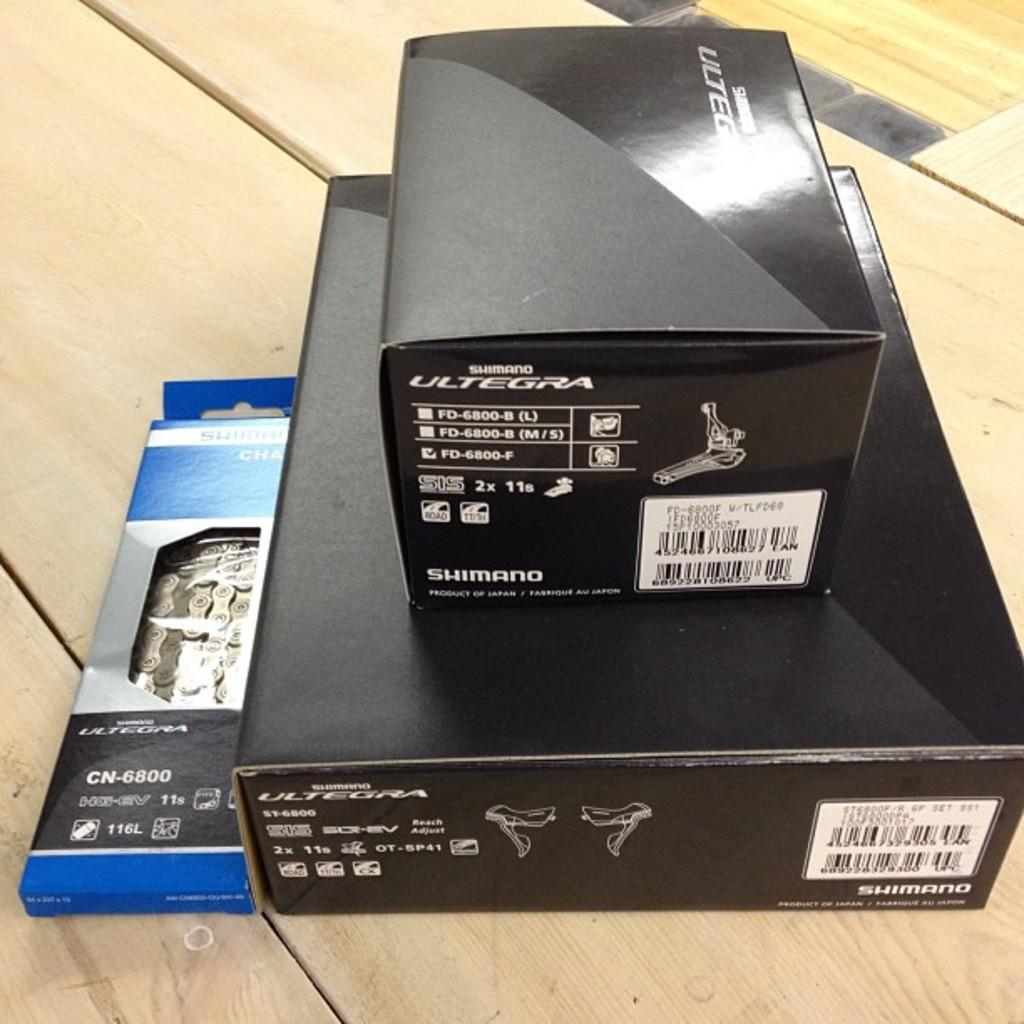<image>
Give a short and clear explanation of the subsequent image. Three packages are grouped together from the company Ultegra. 